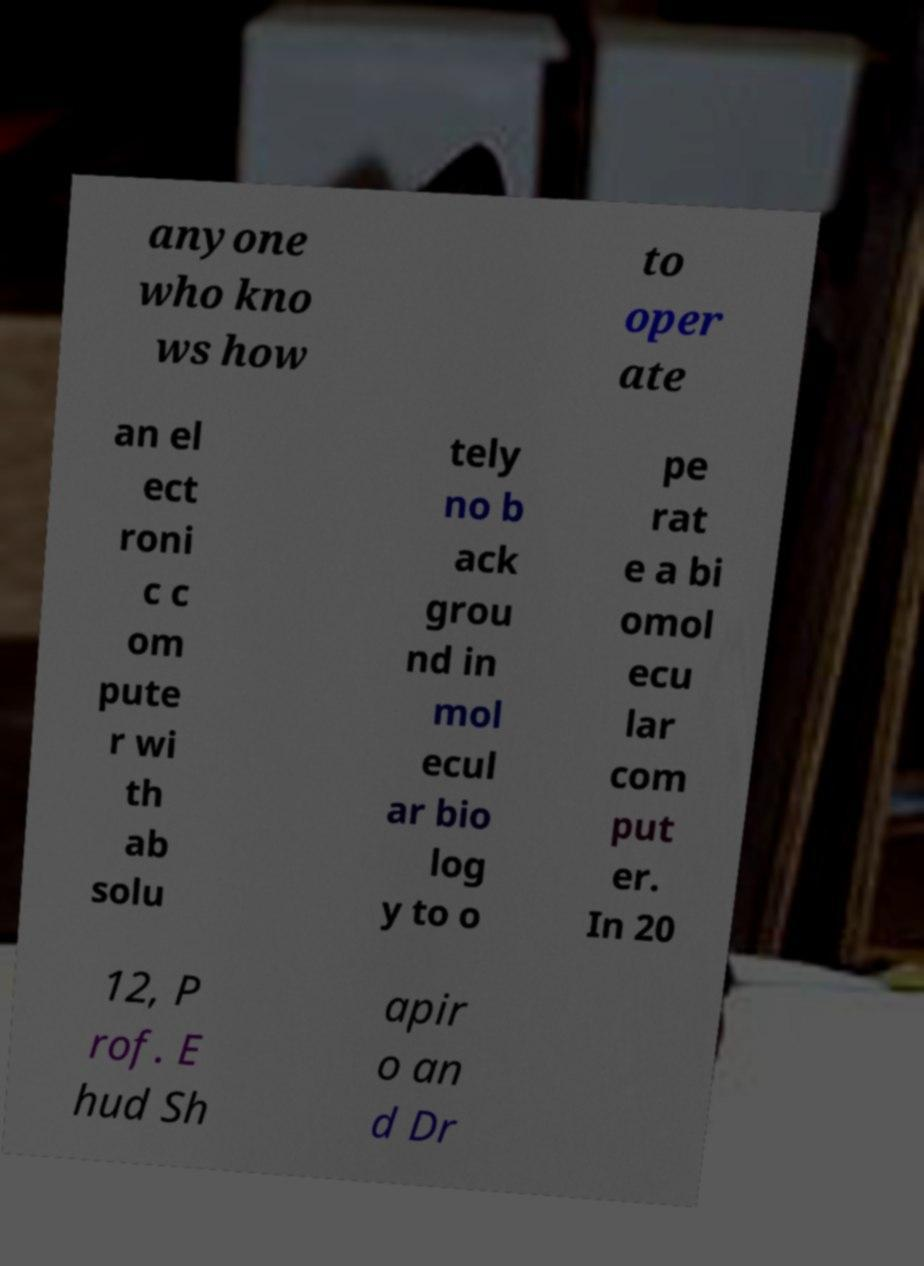What messages or text are displayed in this image? I need them in a readable, typed format. anyone who kno ws how to oper ate an el ect roni c c om pute r wi th ab solu tely no b ack grou nd in mol ecul ar bio log y to o pe rat e a bi omol ecu lar com put er. In 20 12, P rof. E hud Sh apir o an d Dr 